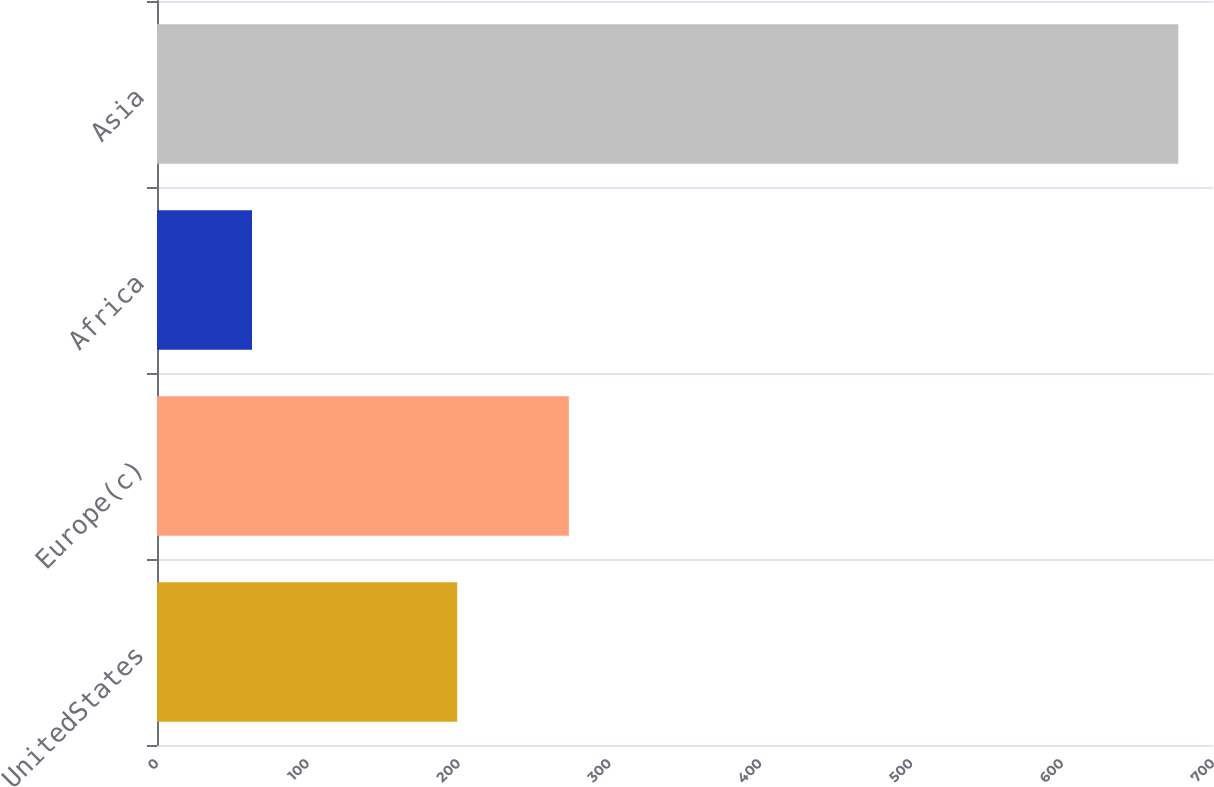<chart> <loc_0><loc_0><loc_500><loc_500><bar_chart><fcel>UnitedStates<fcel>Europe(c)<fcel>Africa<fcel>Asia<nl><fcel>199<fcel>273<fcel>63<fcel>677<nl></chart> 